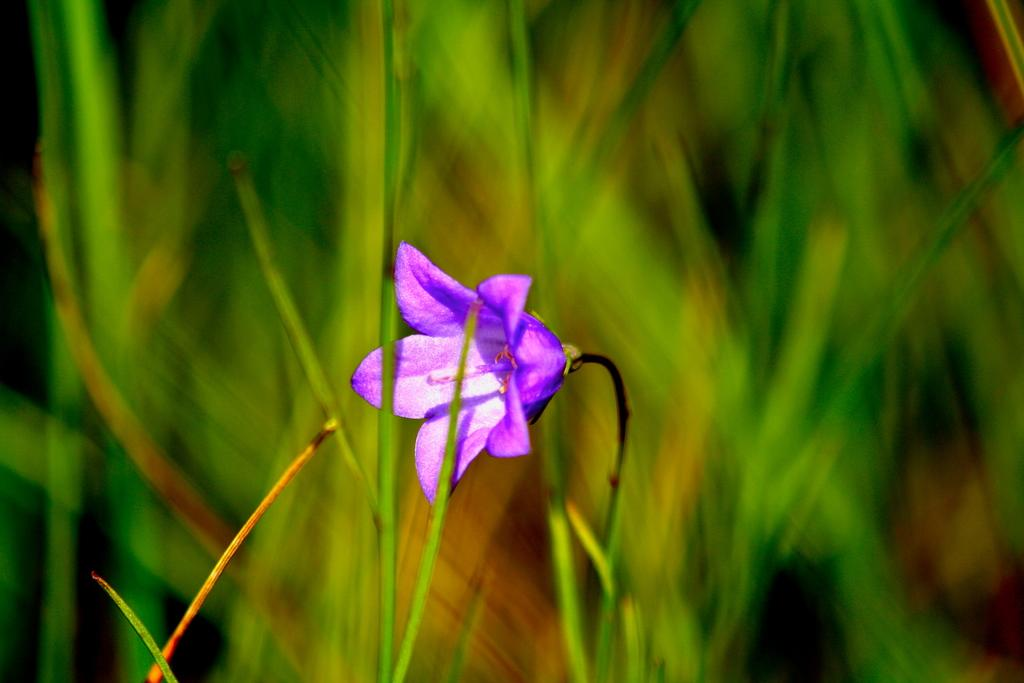What is the main subject of the image? There is a plant in the image. What color is the flower on the plant? The flower on the plant has a violet color. Can you describe the background of the image? The background of the image is blurred. Where is the library located in the image? There is no library present in the image; it features a plant with a violet flower and a blurred background. What type of bed is visible in the image? There is no bed present in the image. 